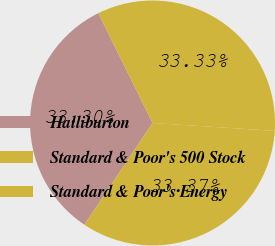Convert chart. <chart><loc_0><loc_0><loc_500><loc_500><pie_chart><fcel>Halliburton<fcel>Standard & Poor's 500 Stock<fcel>Standard & Poor's Energy<nl><fcel>33.3%<fcel>33.33%<fcel>33.37%<nl></chart> 